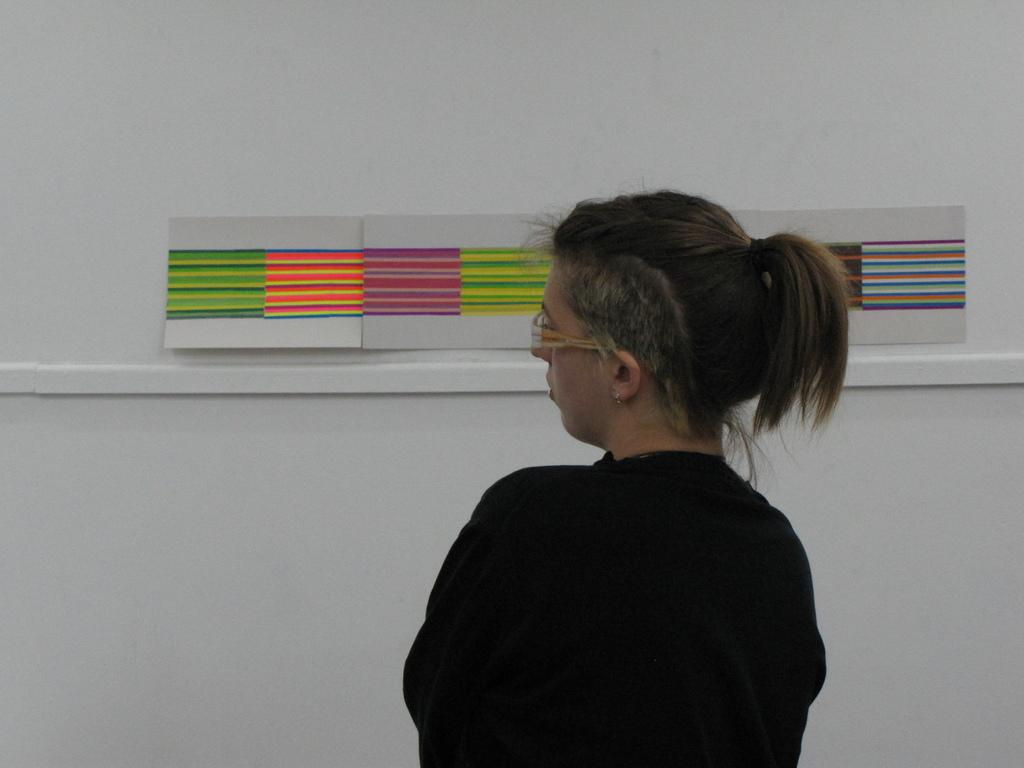Who is the main subject in the image? There is a woman in the image. What is the woman wearing? The woman is wearing a black dress and spectacles. What is the woman's posture in the image? The woman is standing. What can be seen in the background of the image? There is a group of drawings on the wall in the background of the image. How many apples are on the woman's head in the image? There are no apples present on the woman's head in the image. What idea does the woman have while looking at the drawings on the wall? The image does not provide any information about the woman's thoughts or ideas. 